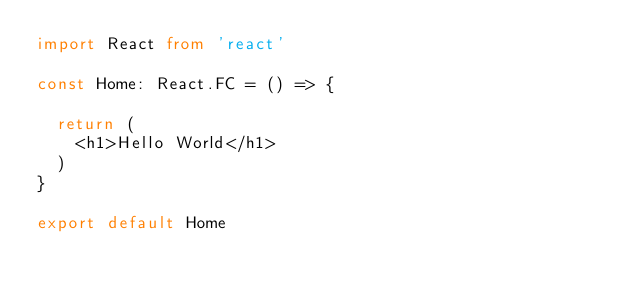<code> <loc_0><loc_0><loc_500><loc_500><_TypeScript_>import React from 'react'

const Home: React.FC = () => {

  return (
    <h1>Hello World</h1>
  )
}

export default Home
</code> 